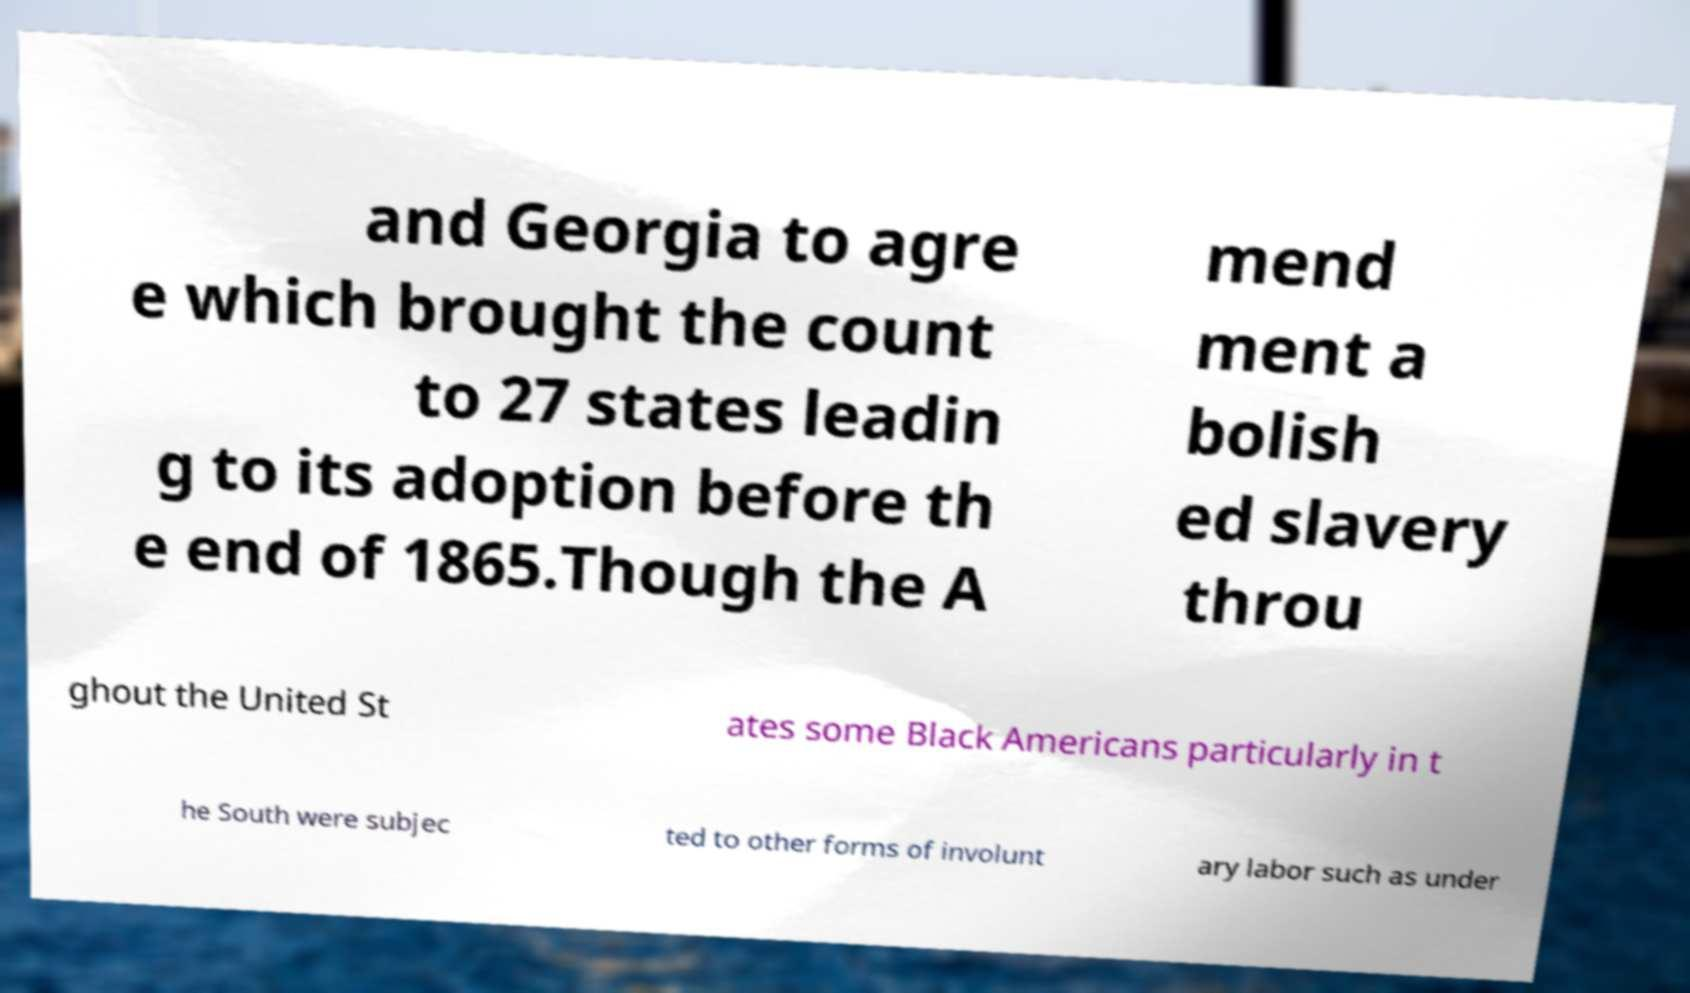Can you read and provide the text displayed in the image?This photo seems to have some interesting text. Can you extract and type it out for me? and Georgia to agre e which brought the count to 27 states leadin g to its adoption before th e end of 1865.Though the A mend ment a bolish ed slavery throu ghout the United St ates some Black Americans particularly in t he South were subjec ted to other forms of involunt ary labor such as under 